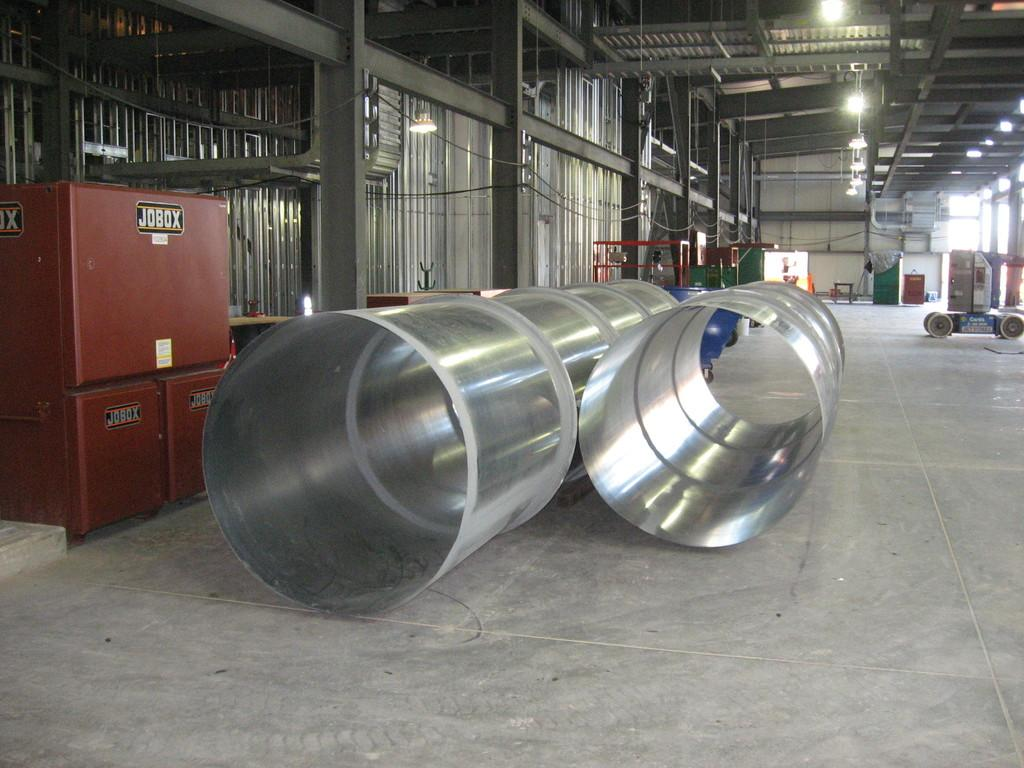What objects are on the floor in the image? There are two big metal pipes on the floor. What is located on the left side of the image? There is a big box on the left side. What can be seen in the background of the image? In the background, there are poles, metal objects, pipes, lights, and a wall. What type of clam is being cooked on the range in the image? There is no range or clam present in the image. How does the ice affect the visibility of the objects in the image? There is no ice present in the image, so it does not affect the visibility of the objects. 